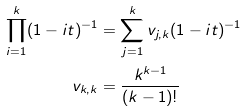<formula> <loc_0><loc_0><loc_500><loc_500>\prod _ { i = 1 } ^ { k } ( 1 - i t ) ^ { - 1 } & = \sum _ { j = 1 } ^ { k } v _ { j , k } ( 1 - i t ) ^ { - 1 } \\ v _ { k , k } & = \frac { k ^ { k - 1 } } { ( k - 1 ) ! }</formula> 